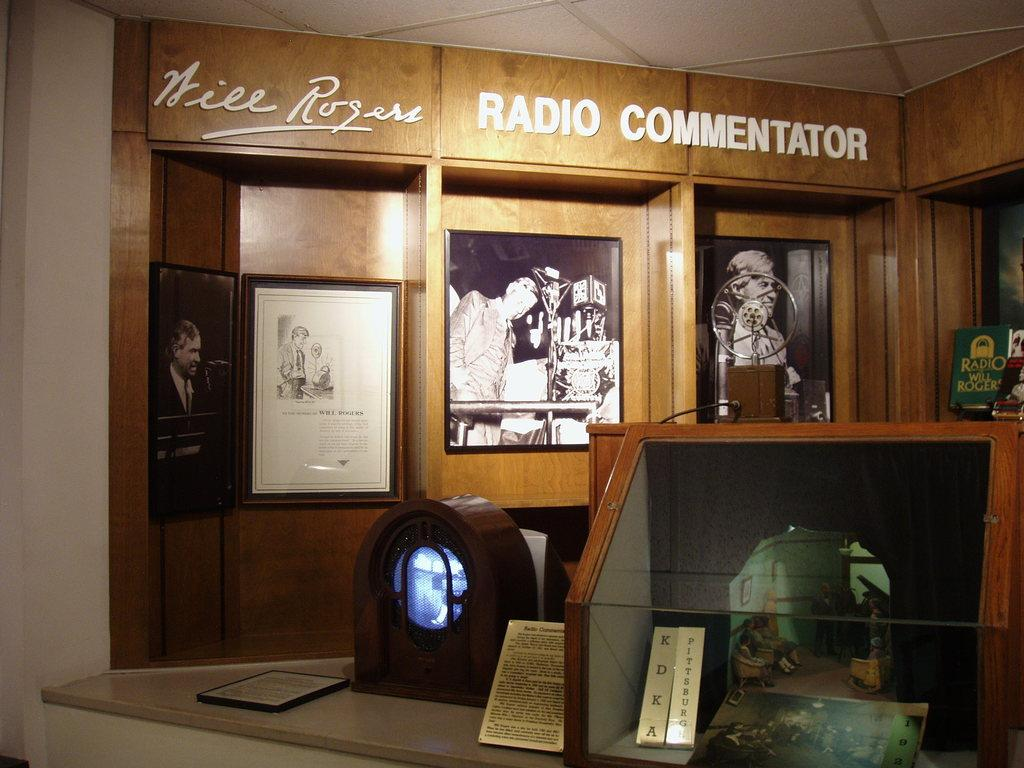<image>
Offer a succinct explanation of the picture presented. Shelf that shows awards and the word "Radio Commentator" on top. 